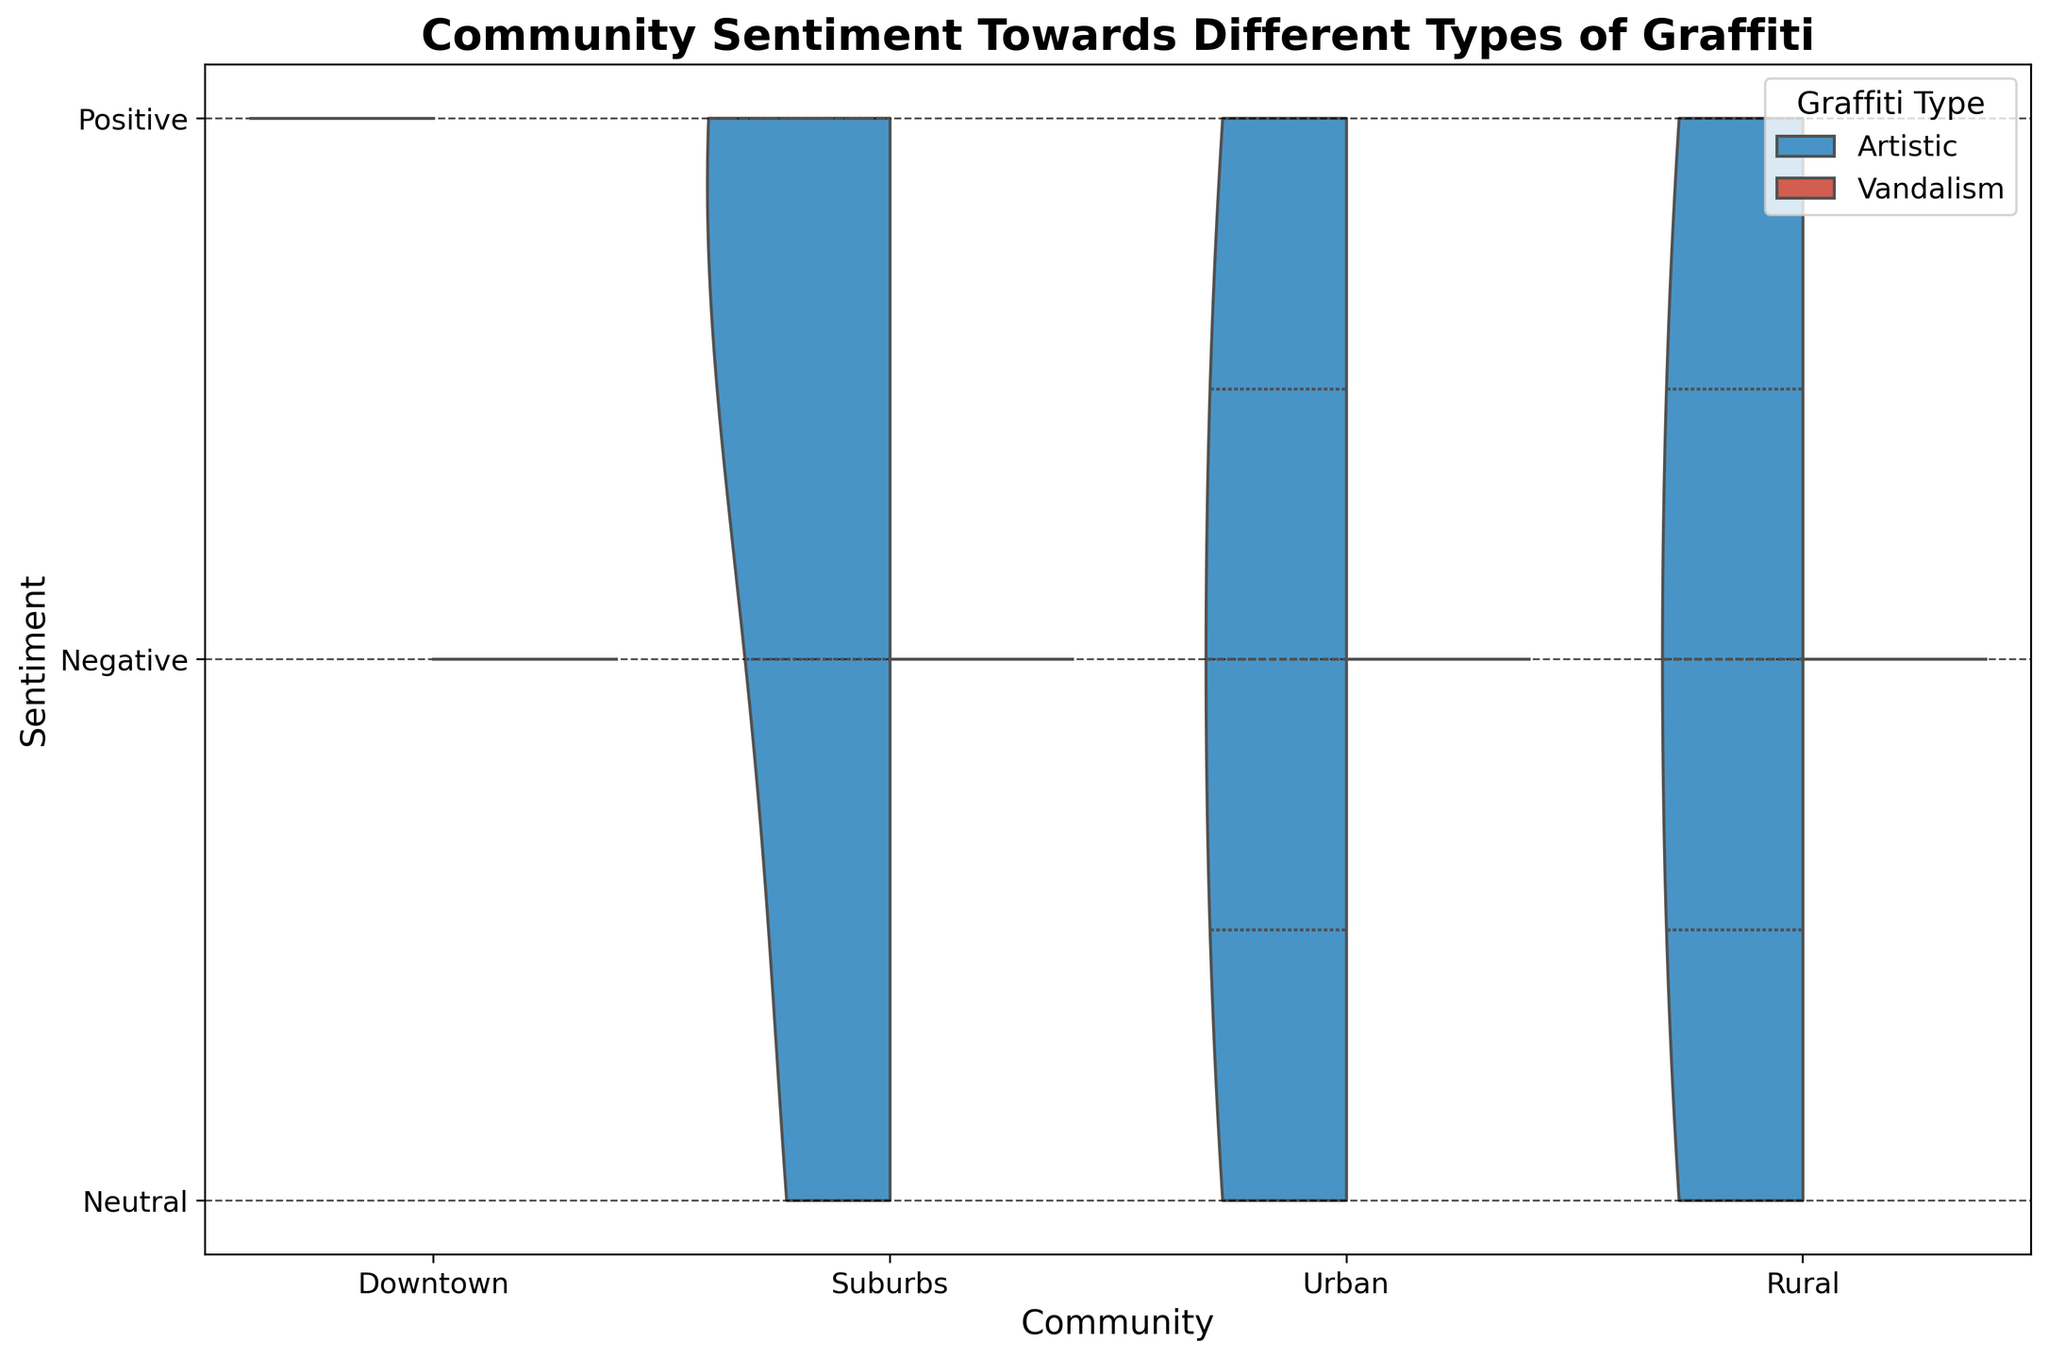What colors are used to represent Artistic and Vandalism graffiti? The split violin plot uses color for differentiation between the types of graffiti. By looking at the plot, you'll see Artistic graffiti is represented in a shade of blue, whereas Vandalism graffiti is in red.
Answer: Blue and Red Which community shows the most neutral sentiment towards Artistic graffiti? To identify this, check for the widest section at the "Neutral" sentiment level within the Artistic half of the violins. In this plot, both Urban and Rural communities have neutral sentiments towards Artistic graffiti.
Answer: Urban and Rural Which type of graffiti does the Downtown community have more negative sentiment towards? Focus on the negative sentiment areas for both Artistic and Vandalism. For the Downtown community, the violin section indicating negative sentiment is much larger for Vandalism.
Answer: Vandalism How does the positive sentiment towards Artistic graffiti in the Suburbs compare to Rural? Compare the positive sections of both split violins for the Suburbs and Rural. The Suburbs have a wider positive sentiment section than the Rural area for Artistic graffiti.
Answer: Suburbs What is the title of the plot? The plot title is located at the top of the figure. It states: "Community Sentiment Towards Different Types of Graffiti".
Answer: Community Sentiment Towards Different Types of Graffiti Which community has the most varied sentiment towards graffiti in general? To determine the most varied sentiment, examine the width of the violins for both Artistic and Vandalism across all communities. Urban shows the widest range in sentiment as it has significant portions across Positive, Neutral, and Negative sentiments for both types of graffiti.
Answer: Urban 